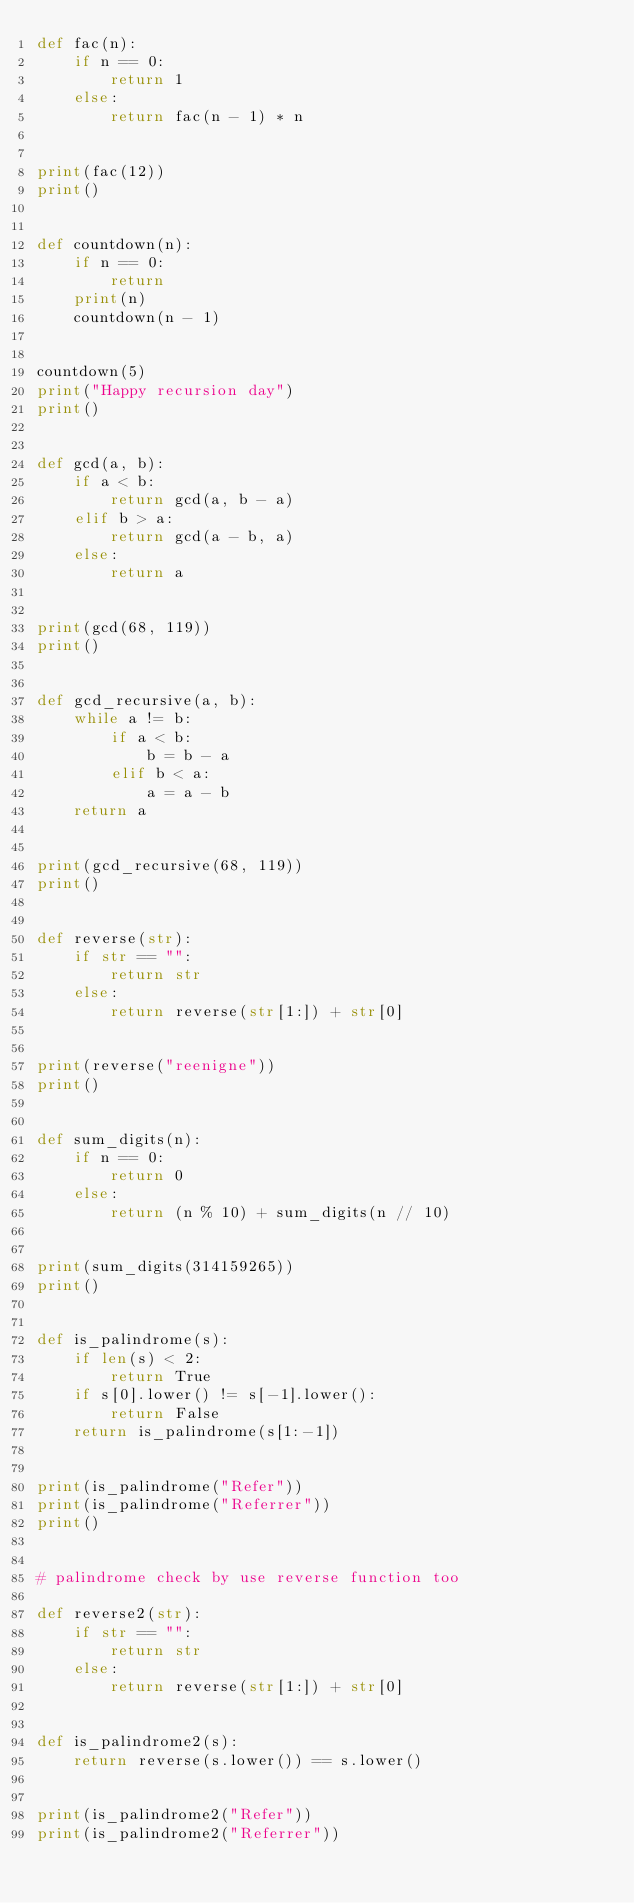<code> <loc_0><loc_0><loc_500><loc_500><_Python_>def fac(n):
    if n == 0:
        return 1
    else:
        return fac(n - 1) * n


print(fac(12))
print()


def countdown(n):
    if n == 0:
        return
    print(n)
    countdown(n - 1)


countdown(5)
print("Happy recursion day")
print()


def gcd(a, b):
    if a < b:
        return gcd(a, b - a)
    elif b > a:
        return gcd(a - b, a)
    else:
        return a


print(gcd(68, 119))
print()


def gcd_recursive(a, b):
    while a != b:
        if a < b:
            b = b - a
        elif b < a:
            a = a - b
    return a


print(gcd_recursive(68, 119))
print()


def reverse(str):
    if str == "":
        return str
    else:
        return reverse(str[1:]) + str[0]


print(reverse("reenigne"))
print()


def sum_digits(n):
    if n == 0:
        return 0
    else:
        return (n % 10) + sum_digits(n // 10)


print(sum_digits(314159265))
print()


def is_palindrome(s):
    if len(s) < 2:
        return True
    if s[0].lower() != s[-1].lower():
        return False
    return is_palindrome(s[1:-1])


print(is_palindrome("Refer"))
print(is_palindrome("Referrer"))
print()


# palindrome check by use reverse function too

def reverse2(str):
    if str == "":
        return str
    else:
        return reverse(str[1:]) + str[0]


def is_palindrome2(s):
    return reverse(s.lower()) == s.lower()


print(is_palindrome2("Refer"))
print(is_palindrome2("Referrer"))
</code> 